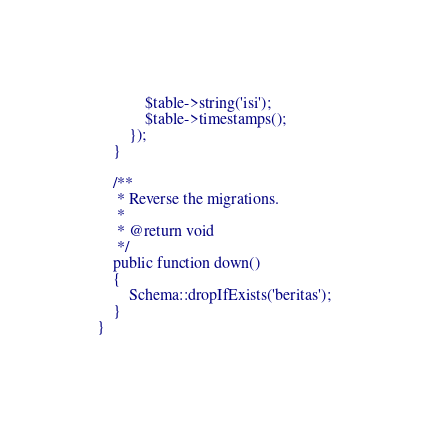Convert code to text. <code><loc_0><loc_0><loc_500><loc_500><_PHP_>            $table->string('isi');
            $table->timestamps();
        });
    }

    /**
     * Reverse the migrations.
     *
     * @return void
     */
    public function down()
    {
        Schema::dropIfExists('beritas');
    }
}
</code> 